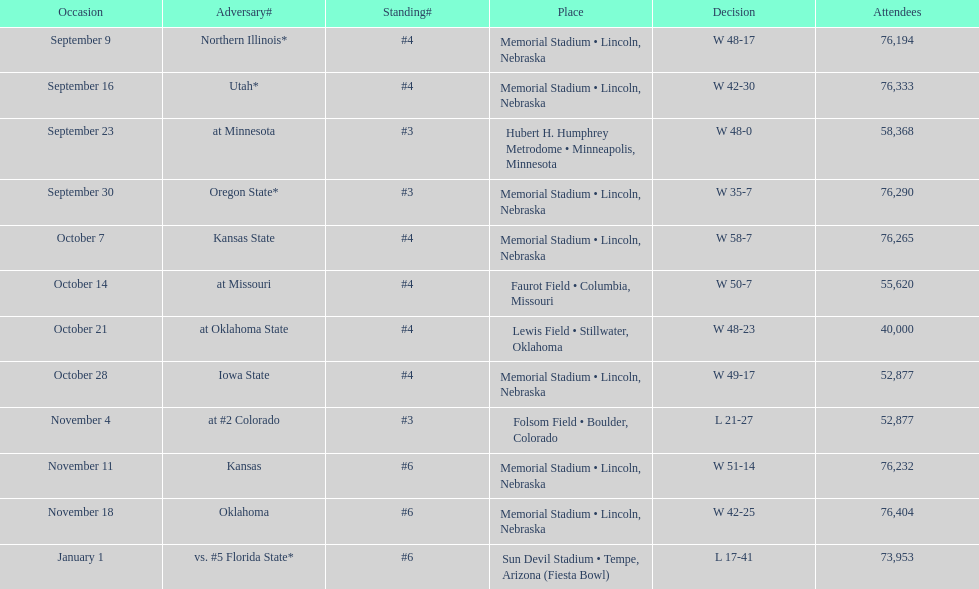When did nebraska play oregon state? September 30. What was the attendance at the september 30 game? 76,290. 